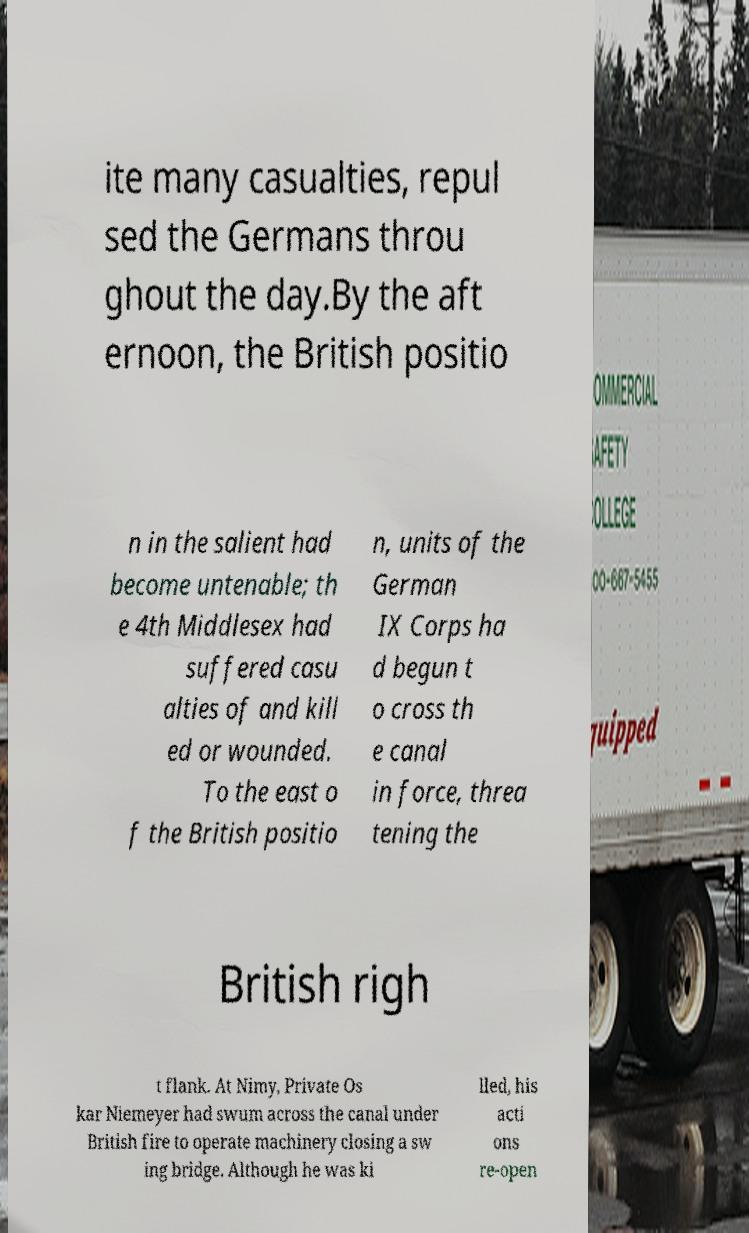Can you accurately transcribe the text from the provided image for me? ite many casualties, repul sed the Germans throu ghout the day.By the aft ernoon, the British positio n in the salient had become untenable; th e 4th Middlesex had suffered casu alties of and kill ed or wounded. To the east o f the British positio n, units of the German IX Corps ha d begun t o cross th e canal in force, threa tening the British righ t flank. At Nimy, Private Os kar Niemeyer had swum across the canal under British fire to operate machinery closing a sw ing bridge. Although he was ki lled, his acti ons re-open 